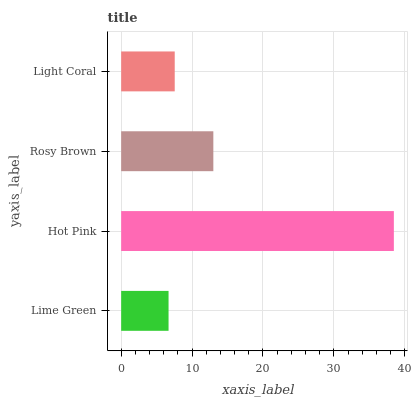Is Lime Green the minimum?
Answer yes or no. Yes. Is Hot Pink the maximum?
Answer yes or no. Yes. Is Rosy Brown the minimum?
Answer yes or no. No. Is Rosy Brown the maximum?
Answer yes or no. No. Is Hot Pink greater than Rosy Brown?
Answer yes or no. Yes. Is Rosy Brown less than Hot Pink?
Answer yes or no. Yes. Is Rosy Brown greater than Hot Pink?
Answer yes or no. No. Is Hot Pink less than Rosy Brown?
Answer yes or no. No. Is Rosy Brown the high median?
Answer yes or no. Yes. Is Light Coral the low median?
Answer yes or no. Yes. Is Lime Green the high median?
Answer yes or no. No. Is Lime Green the low median?
Answer yes or no. No. 